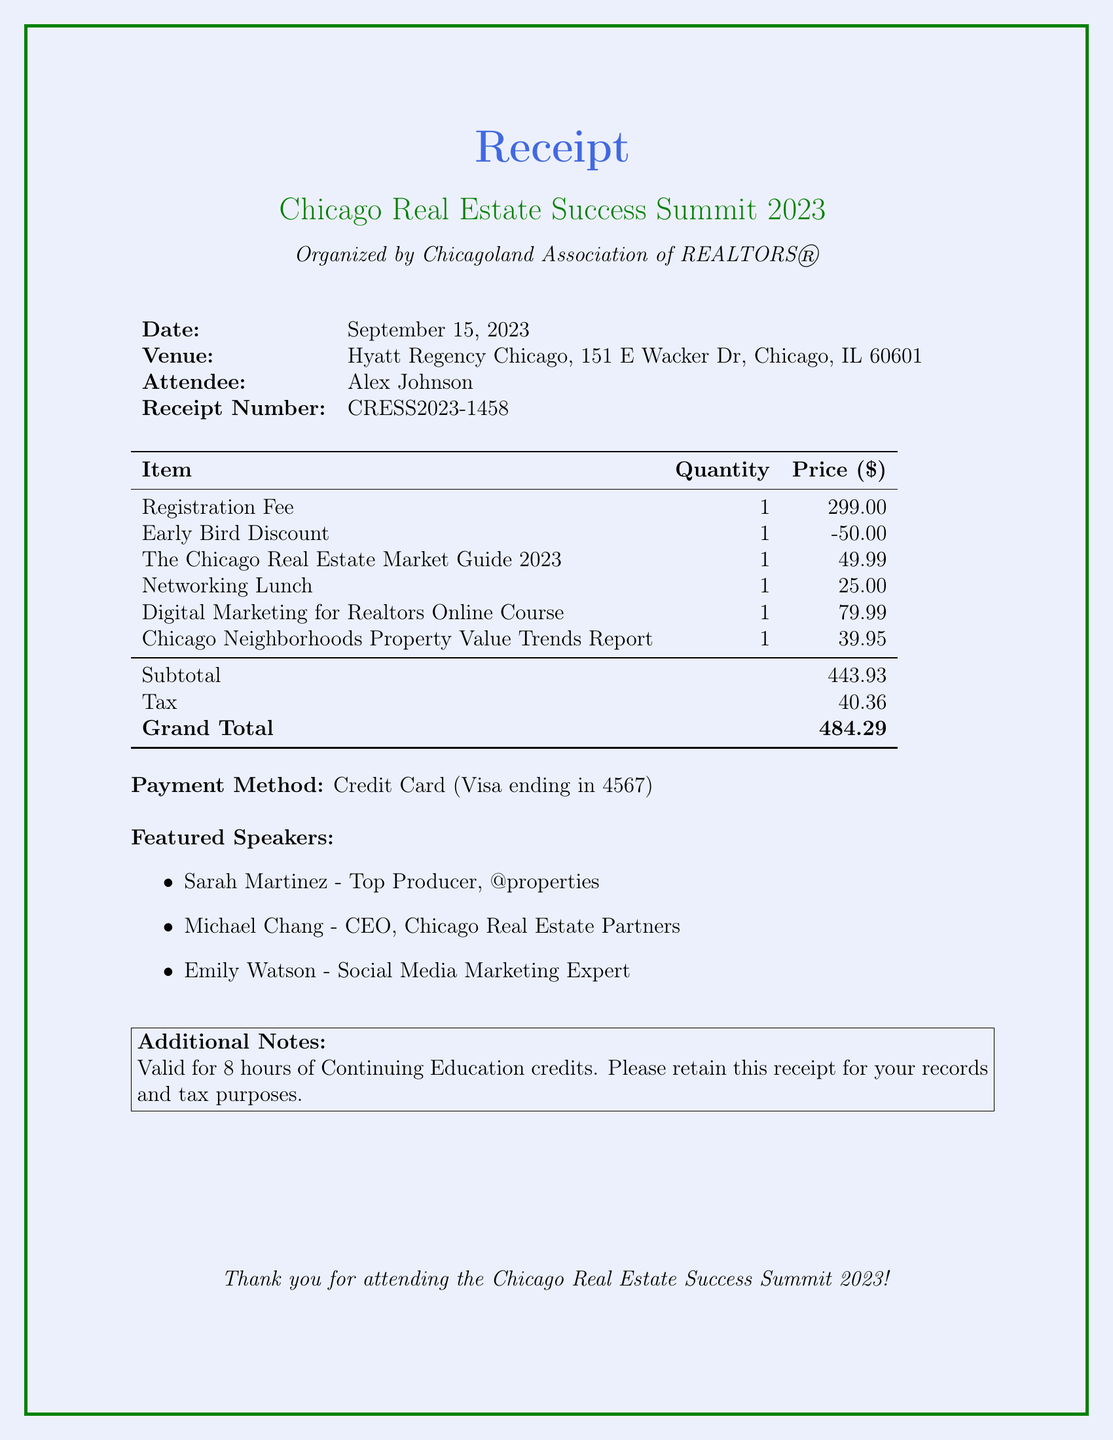what is the seminar name? The seminar name is stated prominently at the top of the receipt.
Answer: Chicago Real Estate Success Summit 2023 what is the date of the seminar? The date of the seminar is listed in the top section of the receipt.
Answer: September 15, 2023 who is the organizer of the seminar? The organizer is mentioned directly under the seminar name.
Answer: Chicagoland Association of REALTORS® what is the total amount paid? The total amount is calculated from the subtotal and tax mentioned in the document.
Answer: 484.29 how much was the registration fee? The registration fee is clearly listed under the itemized costs on the receipt.
Answer: 299.00 what is the early bird discount amount? The early bird discount is specifically stated in the document.
Answer: -50.00 how many speakers are listed in the document? The number of speakers can be counted from the list provided in the receipt.
Answer: 3 what type of payment was used? The payment method is detailed in the bottom part of the receipt.
Answer: Credit Card (Visa ending in 4567) what is the receipt number? The receipt number is mentioned specifically at the top section of the document.
Answer: CRESS2023-1458 what is the purpose of the receipt according to the additional notes? The additional notes clarify the validity of the receipt for education credits.
Answer: Continuing Education credits 